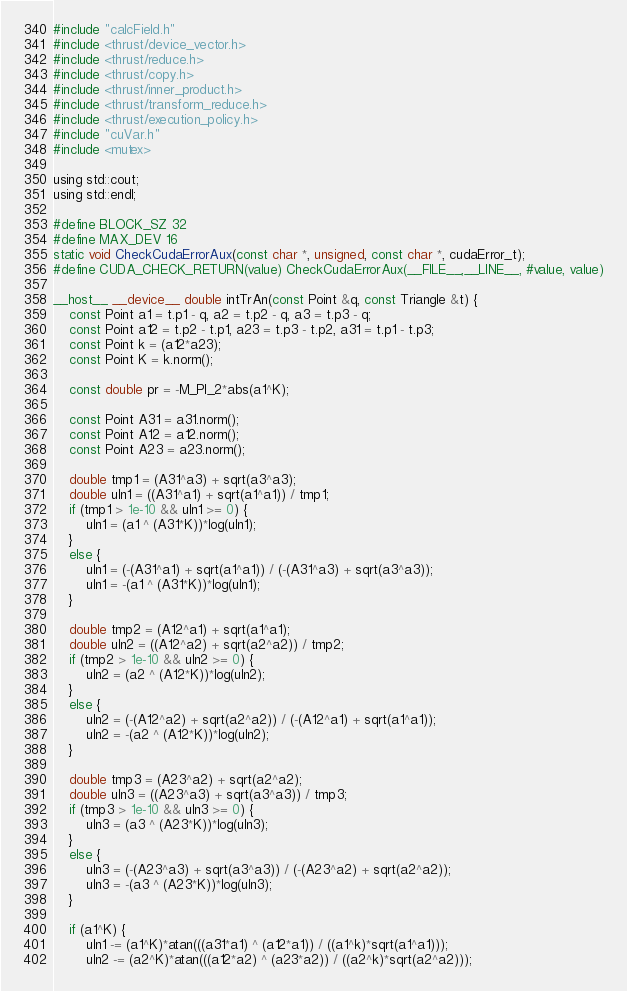<code> <loc_0><loc_0><loc_500><loc_500><_Cuda_>#include "calcField.h"
#include <thrust/device_vector.h>
#include <thrust/reduce.h>
#include <thrust/copy.h>
#include <thrust/inner_product.h>
#include <thrust/transform_reduce.h>
#include <thrust/execution_policy.h>
#include "cuVar.h"
#include <mutex>

using std::cout;
using std::endl;

#define BLOCK_SZ 32
#define MAX_DEV 16
static void CheckCudaErrorAux(const char *, unsigned, const char *, cudaError_t);
#define CUDA_CHECK_RETURN(value) CheckCudaErrorAux(__FILE__,__LINE__, #value, value)

__host__ __device__ double intTrAn(const Point &q, const Triangle &t) {
	const Point a1 = t.p1 - q, a2 = t.p2 - q, a3 = t.p3 - q;
	const Point a12 = t.p2 - t.p1, a23 = t.p3 - t.p2, a31 = t.p1 - t.p3;
	const Point k = (a12*a23);
	const Point K = k.norm();

	const double pr = -M_PI_2*abs(a1^K);

	const Point A31 = a31.norm();
	const Point A12 = a12.norm();
	const Point A23 = a23.norm();

	double tmp1 = (A31^a3) + sqrt(a3^a3);
	double uln1 = ((A31^a1) + sqrt(a1^a1)) / tmp1;
	if (tmp1 > 1e-10 && uln1 >= 0) {
		uln1 = (a1 ^ (A31*K))*log(uln1);
	}
	else {
		uln1 = (-(A31^a1) + sqrt(a1^a1)) / (-(A31^a3) + sqrt(a3^a3));
		uln1 = -(a1 ^ (A31*K))*log(uln1);
	}

	double tmp2 = (A12^a1) + sqrt(a1^a1);
	double uln2 = ((A12^a2) + sqrt(a2^a2)) / tmp2;
	if (tmp2 > 1e-10 && uln2 >= 0) {
		uln2 = (a2 ^ (A12*K))*log(uln2);
	}
	else {
		uln2 = (-(A12^a2) + sqrt(a2^a2)) / (-(A12^a1) + sqrt(a1^a1));
		uln2 = -(a2 ^ (A12*K))*log(uln2);
	}

	double tmp3 = (A23^a2) + sqrt(a2^a2);
	double uln3 = ((A23^a3) + sqrt(a3^a3)) / tmp3;
	if (tmp3 > 1e-10 && uln3 >= 0) {
		uln3 = (a3 ^ (A23*K))*log(uln3);
	}
	else {
		uln3 = (-(A23^a3) + sqrt(a3^a3)) / (-(A23^a2) + sqrt(a2^a2));
		uln3 = -(a3 ^ (A23*K))*log(uln3);
	}

	if (a1^K) {
		uln1 -= (a1^K)*atan(((a31*a1) ^ (a12*a1)) / ((a1^k)*sqrt(a1^a1)));
		uln2 -= (a2^K)*atan(((a12*a2) ^ (a23*a2)) / ((a2^k)*sqrt(a2^a2)));</code> 